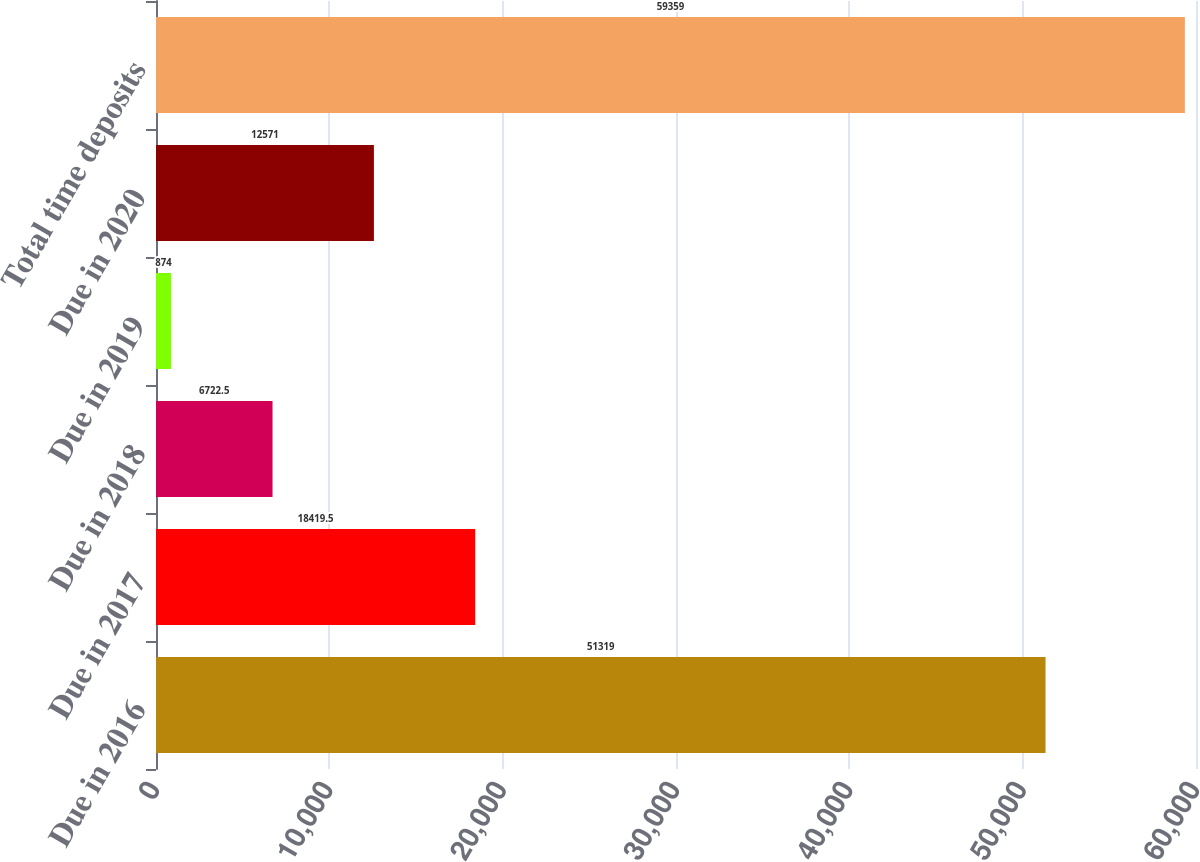<chart> <loc_0><loc_0><loc_500><loc_500><bar_chart><fcel>Due in 2016<fcel>Due in 2017<fcel>Due in 2018<fcel>Due in 2019<fcel>Due in 2020<fcel>Total time deposits<nl><fcel>51319<fcel>18419.5<fcel>6722.5<fcel>874<fcel>12571<fcel>59359<nl></chart> 